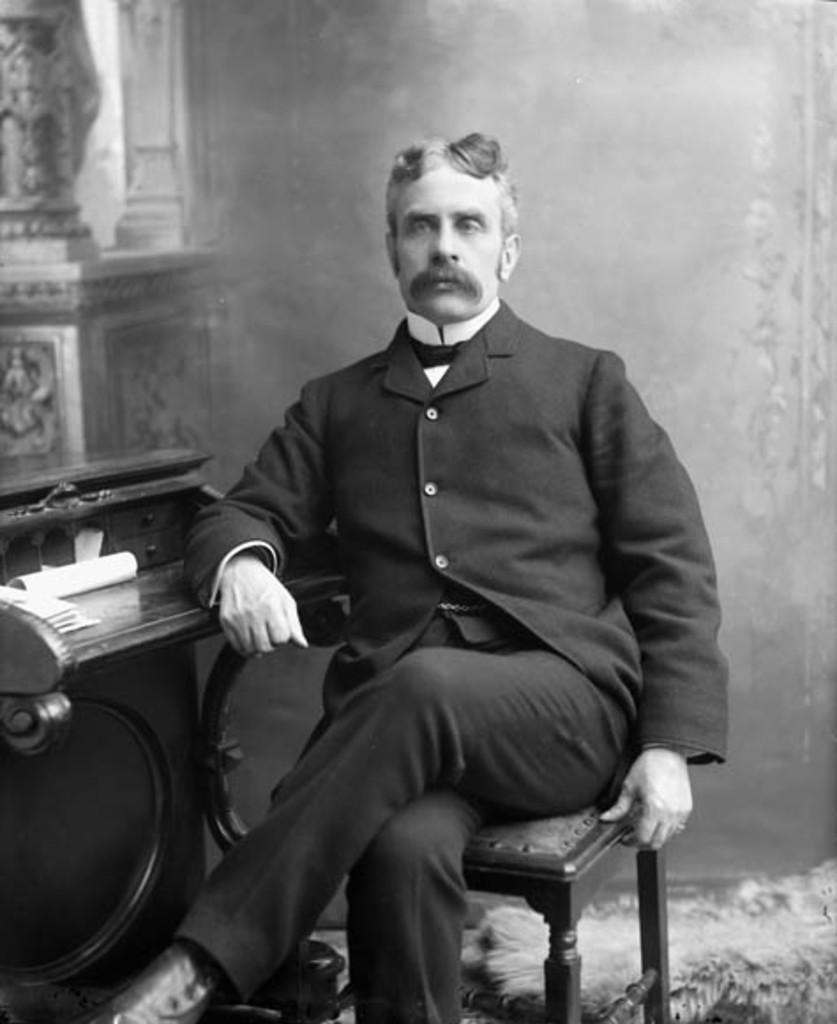In one or two sentences, can you explain what this image depicts? This image is a black and white. In this image there is a person sitting on a chair, beside the person there is a table. On the table there are some objects. In the background there is a wall. 